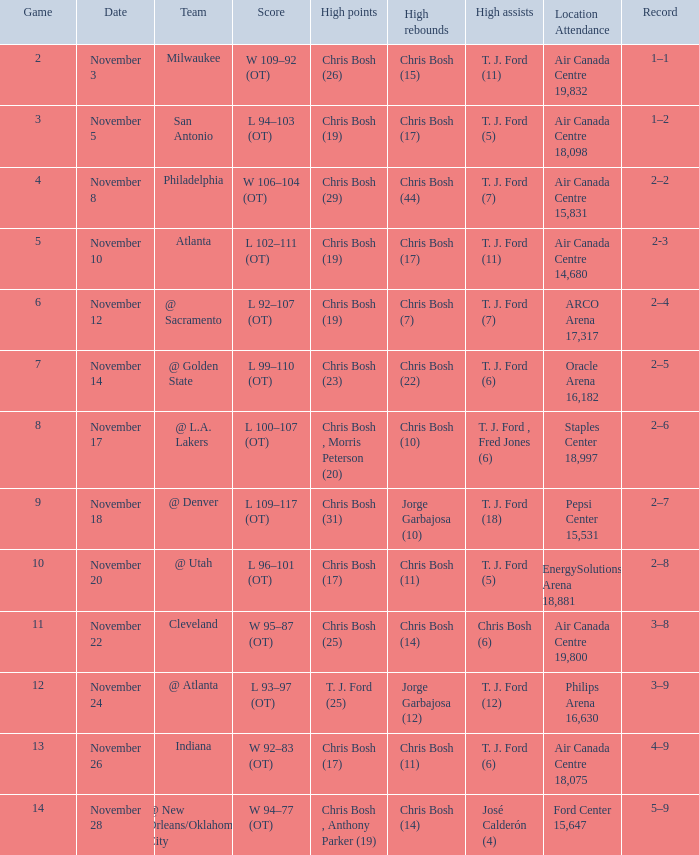What was the score of the game on November 12? L 92–107 (OT). 